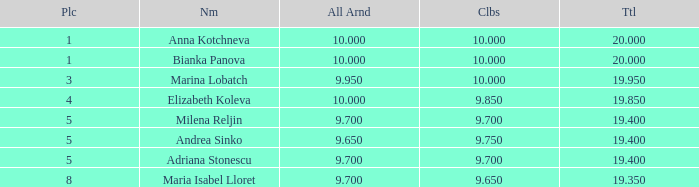What is the highest total that has andrea sinko as the name, with an all around greater than 9.65? None. 